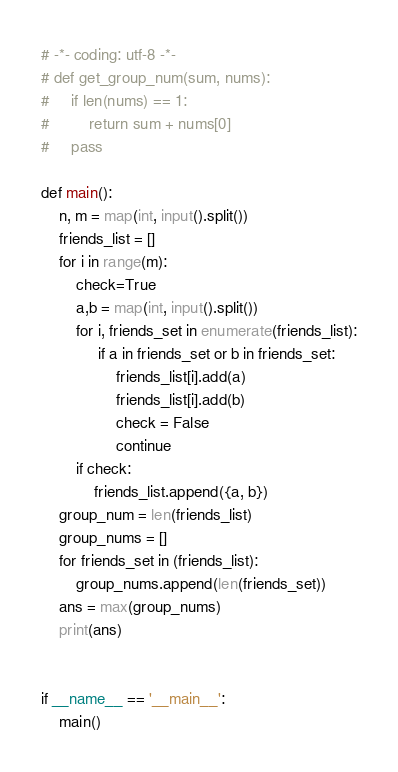Convert code to text. <code><loc_0><loc_0><loc_500><loc_500><_Python_># -*- coding: utf-8 -*-
# def get_group_num(sum, nums):
#     if len(nums) == 1:
#         return sum + nums[0]
#     pass

def main():
    n, m = map(int, input().split())
    friends_list = []
    for i in range(m):
        check=True
        a,b = map(int, input().split())
        for i, friends_set in enumerate(friends_list):
             if a in friends_set or b in friends_set:
                 friends_list[i].add(a)
                 friends_list[i].add(b)
                 check = False
                 continue
        if check:
            friends_list.append({a, b})
    group_num = len(friends_list)
    group_nums = []
    for friends_set in (friends_list):
        group_nums.append(len(friends_set))
    ans = max(group_nums)
    print(ans)
    

if __name__ == '__main__':
    main()</code> 